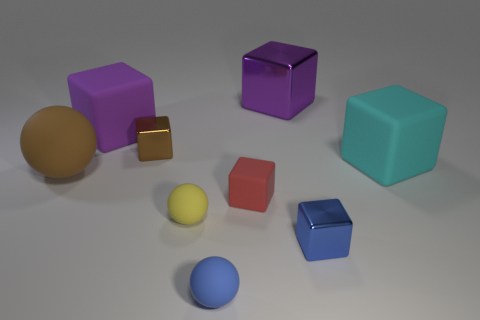Subtract all large cyan matte cubes. How many cubes are left? 5 Subtract all blue blocks. How many blocks are left? 5 Subtract 1 cubes. How many cubes are left? 5 Subtract all gray blocks. Subtract all brown cylinders. How many blocks are left? 6 Add 1 big purple blocks. How many objects exist? 10 Subtract all spheres. How many objects are left? 6 Add 3 large brown spheres. How many large brown spheres are left? 4 Add 8 tiny rubber balls. How many tiny rubber balls exist? 10 Subtract 0 purple cylinders. How many objects are left? 9 Subtract all cyan balls. Subtract all blocks. How many objects are left? 3 